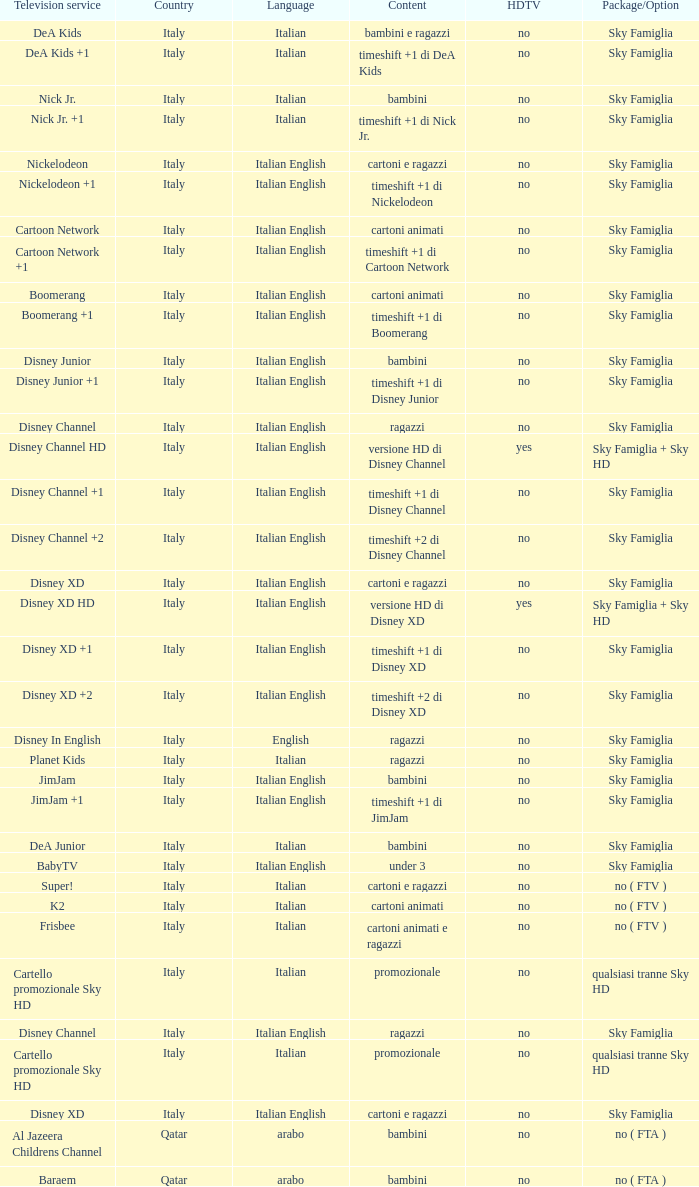What is the Country when the language is italian english, and the television service is disney xd +1? Italy. 